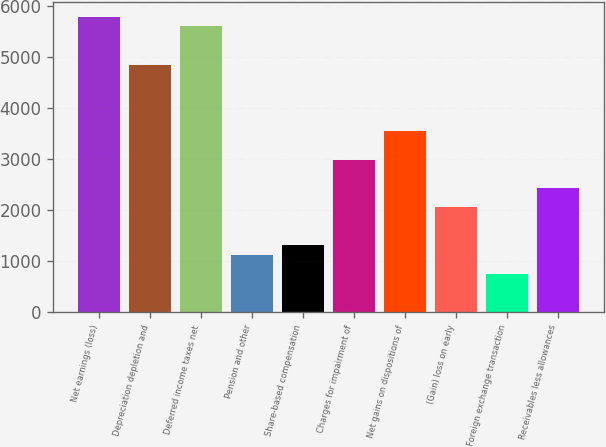Convert chart to OTSL. <chart><loc_0><loc_0><loc_500><loc_500><bar_chart><fcel>Net earnings (loss)<fcel>Depreciation depletion and<fcel>Deferred income taxes net<fcel>Pension and other<fcel>Share-based compensation<fcel>Charges for impairment of<fcel>Net gains on dispositions of<fcel>(Gain) loss on early<fcel>Foreign exchange transaction<fcel>Receivables less allowances<nl><fcel>5789.7<fcel>4856.2<fcel>5603<fcel>1122.2<fcel>1308.9<fcel>2989.2<fcel>3549.3<fcel>2055.7<fcel>748.8<fcel>2429.1<nl></chart> 